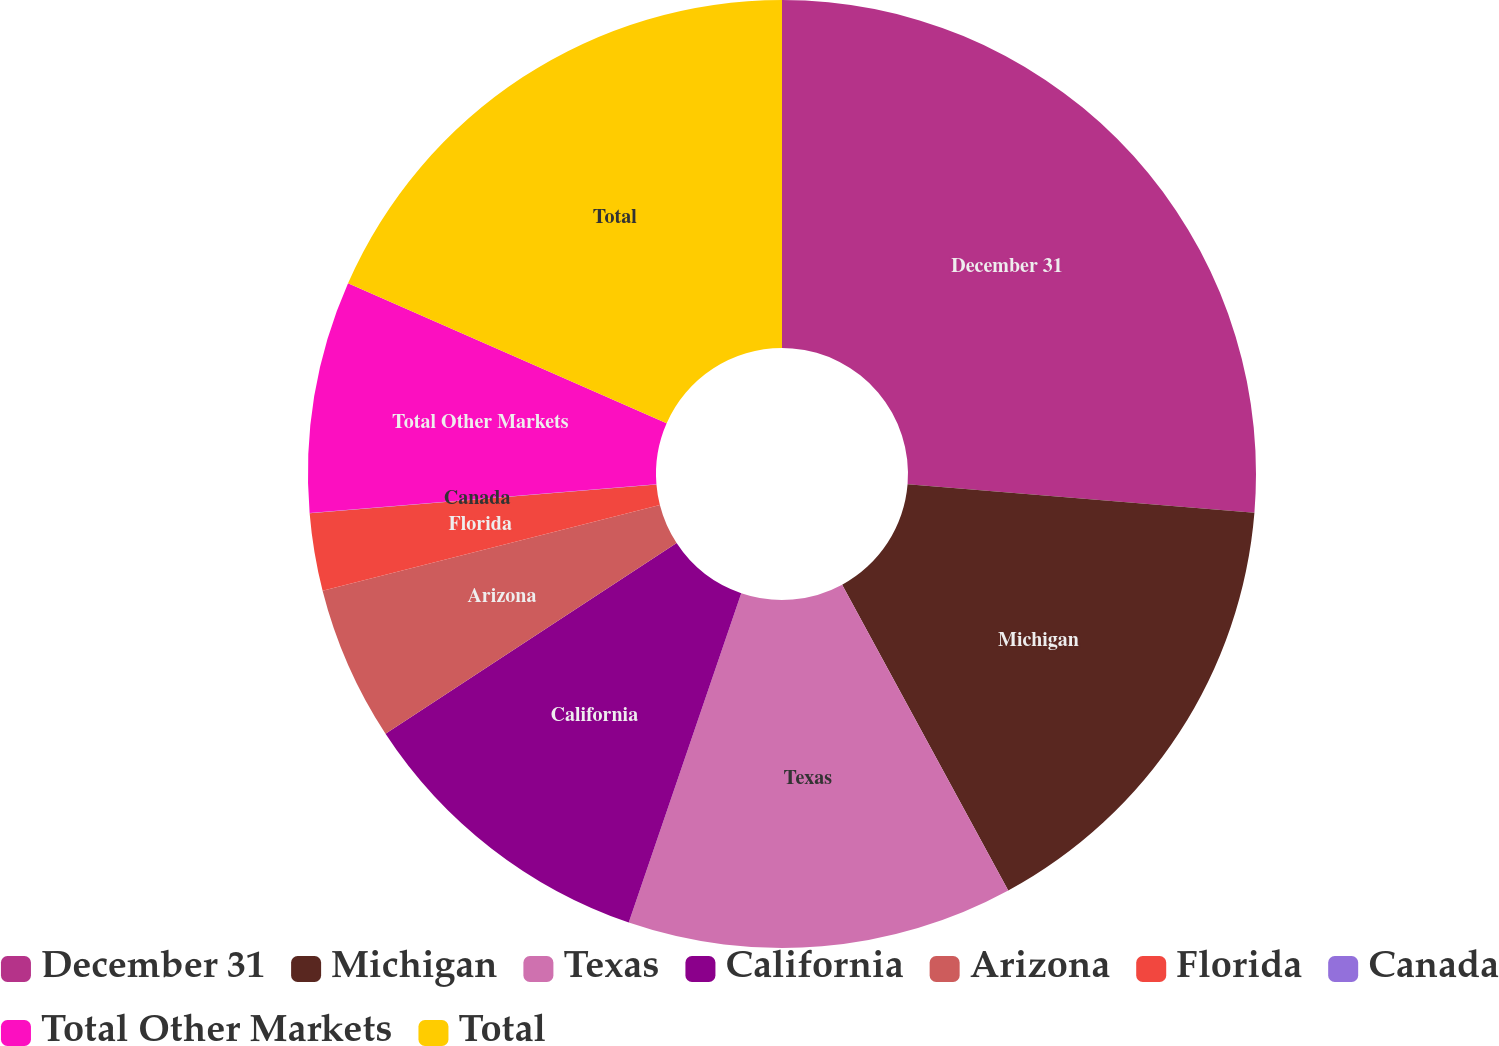Convert chart to OTSL. <chart><loc_0><loc_0><loc_500><loc_500><pie_chart><fcel>December 31<fcel>Michigan<fcel>Texas<fcel>California<fcel>Arizona<fcel>Florida<fcel>Canada<fcel>Total Other Markets<fcel>Total<nl><fcel>26.3%<fcel>15.78%<fcel>13.16%<fcel>10.53%<fcel>5.27%<fcel>2.64%<fcel>0.01%<fcel>7.9%<fcel>18.41%<nl></chart> 